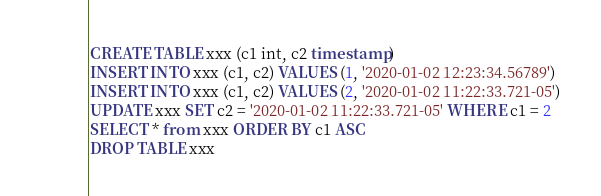<code> <loc_0><loc_0><loc_500><loc_500><_SQL_>CREATE TABLE xxx (c1 int, c2 timestamp)
INSERT INTO xxx (c1, c2) VALUES (1, '2020-01-02 12:23:34.56789')
INSERT INTO xxx (c1, c2) VALUES (2, '2020-01-02 11:22:33.721-05')
UPDATE xxx SET c2 = '2020-01-02 11:22:33.721-05' WHERE c1 = 2
SELECT * from xxx ORDER BY c1 ASC
DROP TABLE xxx</code> 